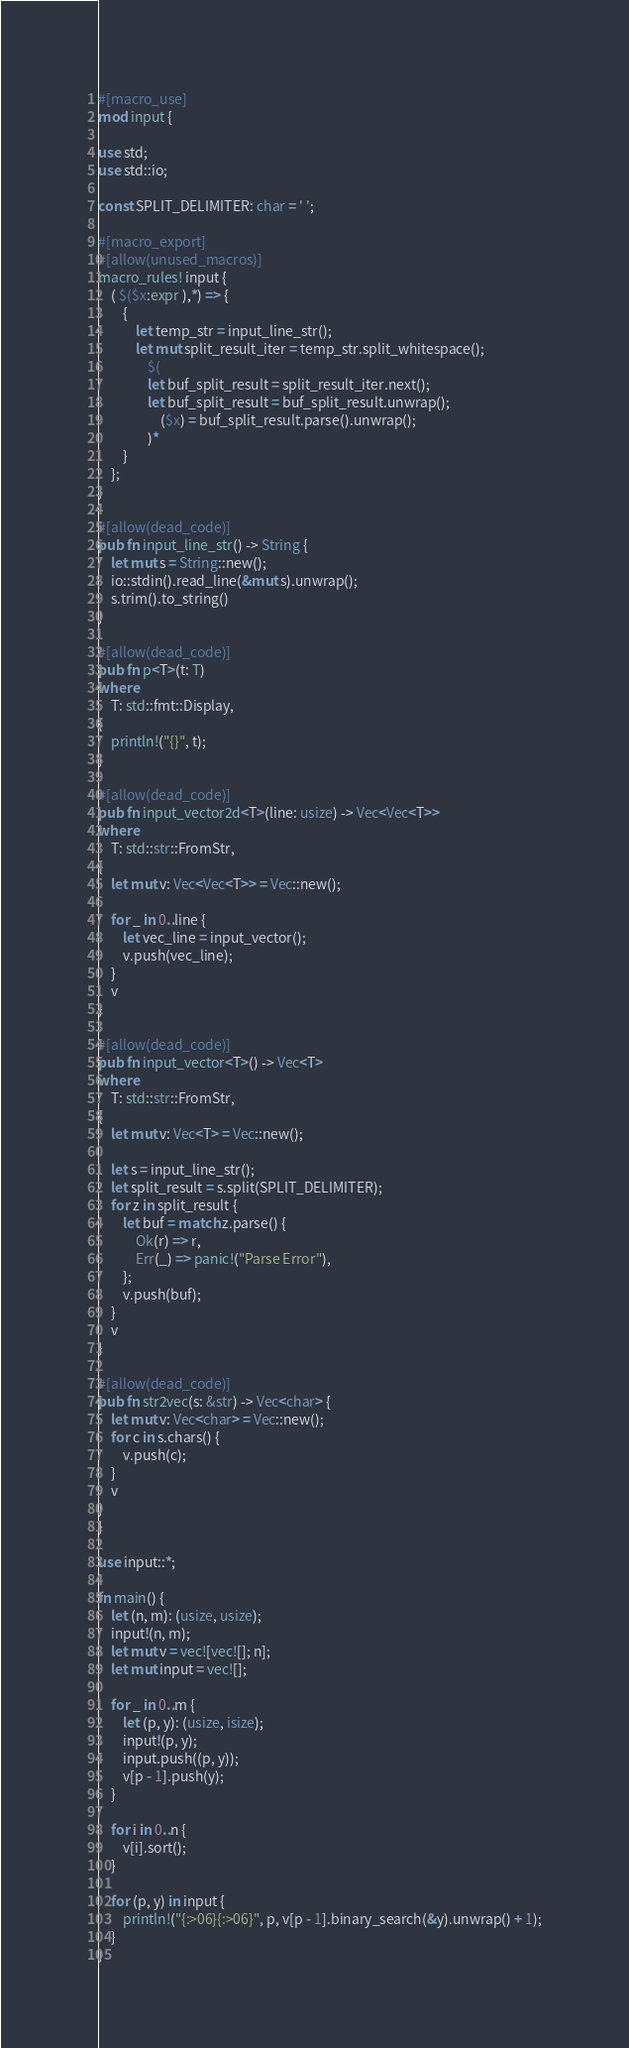Convert code to text. <code><loc_0><loc_0><loc_500><loc_500><_Rust_>#[macro_use]
mod input {

use std;
use std::io;

const SPLIT_DELIMITER: char = ' ';

#[macro_export]
#[allow(unused_macros)]
macro_rules! input {
    ( $($x:expr ),*) => {
        {
            let temp_str = input_line_str();
            let mut split_result_iter = temp_str.split_whitespace();
                $(
                let buf_split_result = split_result_iter.next();
                let buf_split_result = buf_split_result.unwrap();
                    ($x) = buf_split_result.parse().unwrap();
                )*
        }
    };
}

#[allow(dead_code)]
pub fn input_line_str() -> String {
    let mut s = String::new();
    io::stdin().read_line(&mut s).unwrap();
    s.trim().to_string()
}

#[allow(dead_code)]
pub fn p<T>(t: T)
where
    T: std::fmt::Display,
{
    println!("{}", t);
}

#[allow(dead_code)]
pub fn input_vector2d<T>(line: usize) -> Vec<Vec<T>>
where
    T: std::str::FromStr,
{
    let mut v: Vec<Vec<T>> = Vec::new();

    for _ in 0..line {
        let vec_line = input_vector();
        v.push(vec_line);
    }
    v
}

#[allow(dead_code)]
pub fn input_vector<T>() -> Vec<T>
where
    T: std::str::FromStr,
{
    let mut v: Vec<T> = Vec::new();

    let s = input_line_str();
    let split_result = s.split(SPLIT_DELIMITER);
    for z in split_result {
        let buf = match z.parse() {
            Ok(r) => r,
            Err(_) => panic!("Parse Error"),
        };
        v.push(buf);
    }
    v
}

#[allow(dead_code)]
pub fn str2vec(s: &str) -> Vec<char> {
    let mut v: Vec<char> = Vec::new();
    for c in s.chars() {
        v.push(c);
    }
    v
}
}

use input::*;

fn main() {
    let (n, m): (usize, usize);
    input!(n, m);
    let mut v = vec![vec![]; n];
    let mut input = vec![];

    for _ in 0..m {
        let (p, y): (usize, isize);
        input!(p, y);
        input.push((p, y));
        v[p - 1].push(y);
    }

    for i in 0..n {
        v[i].sort();
    }

    for (p, y) in input {
        println!("{:>06}{:>06}", p, v[p - 1].binary_search(&y).unwrap() + 1);
    }
}</code> 